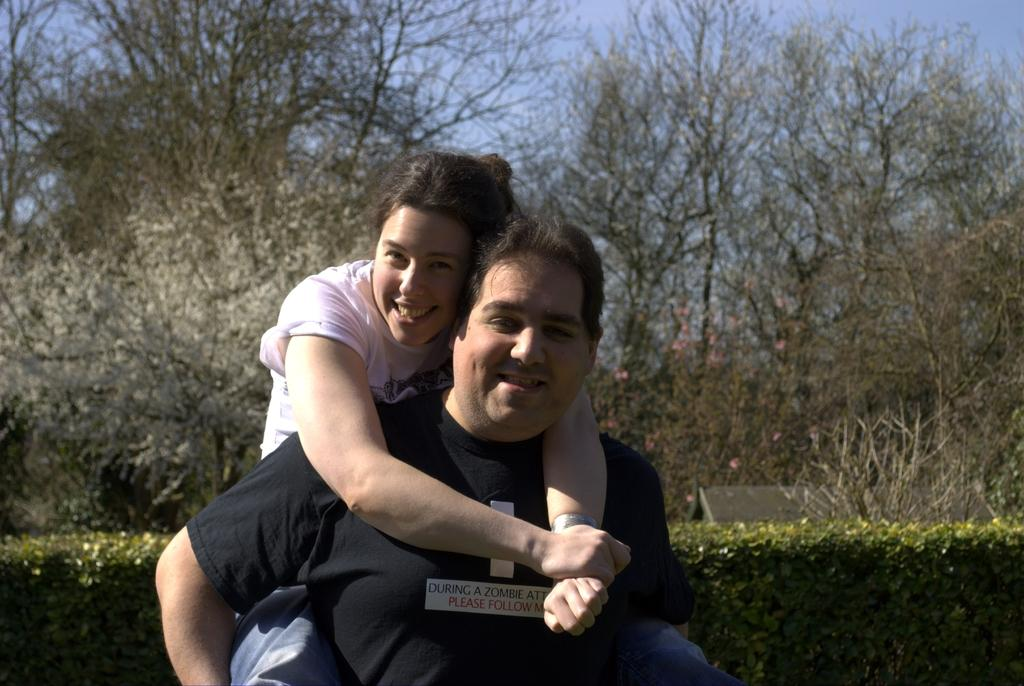How many people are present in the image? There are two people, a man and a woman, present in the image. What expressions do the man and woman have in the image? Both the man and the woman are smiling in the image. What can be seen in the background of the image? There are plants, trees, flowers, and the sky visible in the background of the image. What type of nail polish is the man wearing in the image? There is no mention of nail polish or any indication that the man is wearing nail polish in the image. 